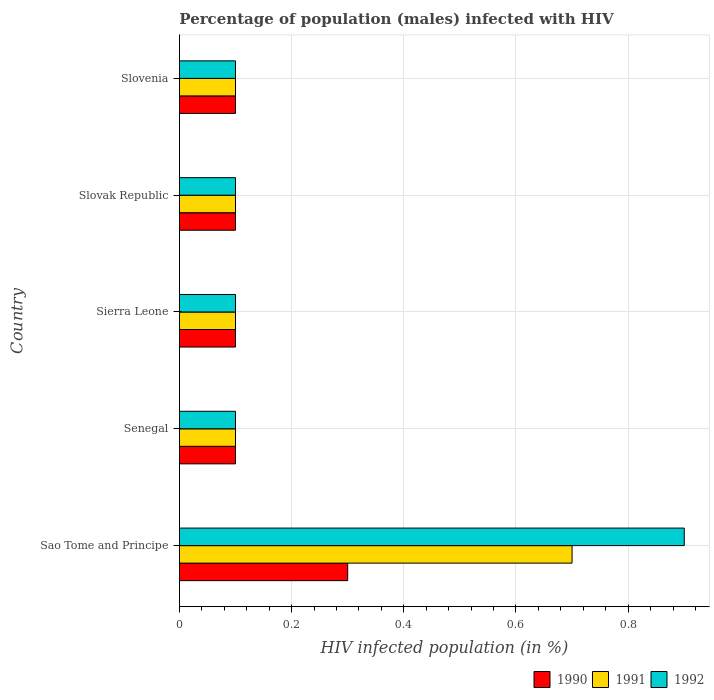How many bars are there on the 2nd tick from the top?
Ensure brevity in your answer.  3. How many bars are there on the 1st tick from the bottom?
Keep it short and to the point. 3. What is the label of the 3rd group of bars from the top?
Your answer should be compact. Sierra Leone. In how many cases, is the number of bars for a given country not equal to the number of legend labels?
Make the answer very short. 0. Across all countries, what is the minimum percentage of HIV infected male population in 1990?
Offer a terse response. 0.1. In which country was the percentage of HIV infected male population in 1992 maximum?
Your answer should be very brief. Sao Tome and Principe. In which country was the percentage of HIV infected male population in 1990 minimum?
Your answer should be very brief. Senegal. What is the total percentage of HIV infected male population in 1990 in the graph?
Your answer should be very brief. 0.7. What is the difference between the percentage of HIV infected male population in 1991 in Sierra Leone and the percentage of HIV infected male population in 1992 in Slovak Republic?
Your response must be concise. 0. What is the average percentage of HIV infected male population in 1991 per country?
Your answer should be compact. 0.22. In how many countries, is the percentage of HIV infected male population in 1992 greater than 0.2 %?
Keep it short and to the point. 1. Is the percentage of HIV infected male population in 1991 in Senegal less than that in Slovenia?
Provide a succinct answer. No. What is the difference between the highest and the second highest percentage of HIV infected male population in 1990?
Your response must be concise. 0.2. What is the difference between the highest and the lowest percentage of HIV infected male population in 1990?
Give a very brief answer. 0.2. In how many countries, is the percentage of HIV infected male population in 1991 greater than the average percentage of HIV infected male population in 1991 taken over all countries?
Provide a short and direct response. 1. Is the sum of the percentage of HIV infected male population in 1992 in Sao Tome and Principe and Slovenia greater than the maximum percentage of HIV infected male population in 1991 across all countries?
Your response must be concise. Yes. What does the 1st bar from the top in Sao Tome and Principe represents?
Give a very brief answer. 1992. How many bars are there?
Ensure brevity in your answer.  15. What is the difference between two consecutive major ticks on the X-axis?
Provide a short and direct response. 0.2. Does the graph contain any zero values?
Offer a terse response. No. Where does the legend appear in the graph?
Give a very brief answer. Bottom right. How many legend labels are there?
Give a very brief answer. 3. How are the legend labels stacked?
Provide a short and direct response. Horizontal. What is the title of the graph?
Provide a short and direct response. Percentage of population (males) infected with HIV. What is the label or title of the X-axis?
Your response must be concise. HIV infected population (in %). What is the label or title of the Y-axis?
Provide a succinct answer. Country. What is the HIV infected population (in %) in 1990 in Sao Tome and Principe?
Make the answer very short. 0.3. What is the HIV infected population (in %) of 1991 in Sierra Leone?
Make the answer very short. 0.1. What is the HIV infected population (in %) of 1991 in Slovak Republic?
Provide a succinct answer. 0.1. What is the HIV infected population (in %) in 1992 in Slovenia?
Your answer should be compact. 0.1. Across all countries, what is the maximum HIV infected population (in %) in 1990?
Your response must be concise. 0.3. Across all countries, what is the maximum HIV infected population (in %) in 1991?
Your answer should be compact. 0.7. Across all countries, what is the minimum HIV infected population (in %) of 1991?
Give a very brief answer. 0.1. What is the total HIV infected population (in %) of 1990 in the graph?
Make the answer very short. 0.7. What is the total HIV infected population (in %) of 1991 in the graph?
Keep it short and to the point. 1.1. What is the total HIV infected population (in %) in 1992 in the graph?
Give a very brief answer. 1.3. What is the difference between the HIV infected population (in %) of 1990 in Sao Tome and Principe and that in Senegal?
Provide a short and direct response. 0.2. What is the difference between the HIV infected population (in %) of 1991 in Sao Tome and Principe and that in Senegal?
Keep it short and to the point. 0.6. What is the difference between the HIV infected population (in %) of 1992 in Sao Tome and Principe and that in Senegal?
Give a very brief answer. 0.8. What is the difference between the HIV infected population (in %) in 1990 in Sao Tome and Principe and that in Sierra Leone?
Ensure brevity in your answer.  0.2. What is the difference between the HIV infected population (in %) in 1992 in Sao Tome and Principe and that in Sierra Leone?
Make the answer very short. 0.8. What is the difference between the HIV infected population (in %) of 1991 in Sao Tome and Principe and that in Slovenia?
Offer a very short reply. 0.6. What is the difference between the HIV infected population (in %) in 1992 in Sao Tome and Principe and that in Slovenia?
Keep it short and to the point. 0.8. What is the difference between the HIV infected population (in %) in 1990 in Senegal and that in Slovak Republic?
Keep it short and to the point. 0. What is the difference between the HIV infected population (in %) of 1992 in Senegal and that in Slovak Republic?
Ensure brevity in your answer.  0. What is the difference between the HIV infected population (in %) of 1992 in Senegal and that in Slovenia?
Your response must be concise. 0. What is the difference between the HIV infected population (in %) of 1991 in Sierra Leone and that in Slovak Republic?
Offer a very short reply. 0. What is the difference between the HIV infected population (in %) in 1991 in Sierra Leone and that in Slovenia?
Your answer should be compact. 0. What is the difference between the HIV infected population (in %) in 1991 in Sao Tome and Principe and the HIV infected population (in %) in 1992 in Senegal?
Provide a short and direct response. 0.6. What is the difference between the HIV infected population (in %) in 1990 in Sao Tome and Principe and the HIV infected population (in %) in 1991 in Sierra Leone?
Ensure brevity in your answer.  0.2. What is the difference between the HIV infected population (in %) of 1990 in Sao Tome and Principe and the HIV infected population (in %) of 1991 in Slovak Republic?
Make the answer very short. 0.2. What is the difference between the HIV infected population (in %) of 1990 in Sao Tome and Principe and the HIV infected population (in %) of 1992 in Slovenia?
Make the answer very short. 0.2. What is the difference between the HIV infected population (in %) in 1990 in Senegal and the HIV infected population (in %) in 1992 in Sierra Leone?
Offer a terse response. 0. What is the difference between the HIV infected population (in %) in 1990 in Senegal and the HIV infected population (in %) in 1991 in Slovak Republic?
Offer a terse response. 0. What is the difference between the HIV infected population (in %) in 1990 in Senegal and the HIV infected population (in %) in 1991 in Slovenia?
Ensure brevity in your answer.  0. What is the difference between the HIV infected population (in %) of 1990 in Senegal and the HIV infected population (in %) of 1992 in Slovenia?
Offer a very short reply. 0. What is the difference between the HIV infected population (in %) of 1990 in Sierra Leone and the HIV infected population (in %) of 1991 in Slovak Republic?
Your answer should be compact. 0. What is the difference between the HIV infected population (in %) in 1990 in Sierra Leone and the HIV infected population (in %) in 1992 in Slovak Republic?
Your answer should be compact. 0. What is the difference between the HIV infected population (in %) in 1990 in Sierra Leone and the HIV infected population (in %) in 1991 in Slovenia?
Provide a succinct answer. 0. What is the difference between the HIV infected population (in %) of 1990 in Slovak Republic and the HIV infected population (in %) of 1992 in Slovenia?
Your answer should be very brief. 0. What is the average HIV infected population (in %) of 1990 per country?
Ensure brevity in your answer.  0.14. What is the average HIV infected population (in %) in 1991 per country?
Provide a succinct answer. 0.22. What is the average HIV infected population (in %) of 1992 per country?
Your answer should be very brief. 0.26. What is the difference between the HIV infected population (in %) of 1990 and HIV infected population (in %) of 1991 in Sao Tome and Principe?
Provide a succinct answer. -0.4. What is the difference between the HIV infected population (in %) of 1991 and HIV infected population (in %) of 1992 in Sao Tome and Principe?
Offer a very short reply. -0.2. What is the difference between the HIV infected population (in %) in 1990 and HIV infected population (in %) in 1991 in Sierra Leone?
Make the answer very short. 0. What is the difference between the HIV infected population (in %) of 1990 and HIV infected population (in %) of 1991 in Slovak Republic?
Provide a short and direct response. 0. What is the difference between the HIV infected population (in %) of 1990 and HIV infected population (in %) of 1992 in Slovak Republic?
Give a very brief answer. 0. What is the difference between the HIV infected population (in %) of 1991 and HIV infected population (in %) of 1992 in Slovak Republic?
Your response must be concise. 0. What is the difference between the HIV infected population (in %) of 1990 and HIV infected population (in %) of 1992 in Slovenia?
Offer a very short reply. 0. What is the difference between the HIV infected population (in %) of 1991 and HIV infected population (in %) of 1992 in Slovenia?
Ensure brevity in your answer.  0. What is the ratio of the HIV infected population (in %) in 1991 in Sao Tome and Principe to that in Senegal?
Give a very brief answer. 7. What is the ratio of the HIV infected population (in %) in 1992 in Sao Tome and Principe to that in Senegal?
Offer a terse response. 9. What is the ratio of the HIV infected population (in %) of 1990 in Sao Tome and Principe to that in Sierra Leone?
Offer a terse response. 3. What is the ratio of the HIV infected population (in %) in 1991 in Sao Tome and Principe to that in Sierra Leone?
Give a very brief answer. 7. What is the ratio of the HIV infected population (in %) in 1990 in Sao Tome and Principe to that in Slovenia?
Your answer should be very brief. 3. What is the ratio of the HIV infected population (in %) of 1992 in Sao Tome and Principe to that in Slovenia?
Make the answer very short. 9. What is the ratio of the HIV infected population (in %) of 1990 in Senegal to that in Slovak Republic?
Keep it short and to the point. 1. What is the ratio of the HIV infected population (in %) of 1992 in Senegal to that in Slovak Republic?
Keep it short and to the point. 1. What is the ratio of the HIV infected population (in %) of 1991 in Sierra Leone to that in Slovak Republic?
Make the answer very short. 1. What is the ratio of the HIV infected population (in %) in 1992 in Sierra Leone to that in Slovak Republic?
Ensure brevity in your answer.  1. What is the ratio of the HIV infected population (in %) in 1990 in Sierra Leone to that in Slovenia?
Provide a succinct answer. 1. What is the ratio of the HIV infected population (in %) in 1991 in Sierra Leone to that in Slovenia?
Provide a short and direct response. 1. What is the ratio of the HIV infected population (in %) of 1992 in Sierra Leone to that in Slovenia?
Provide a succinct answer. 1. 